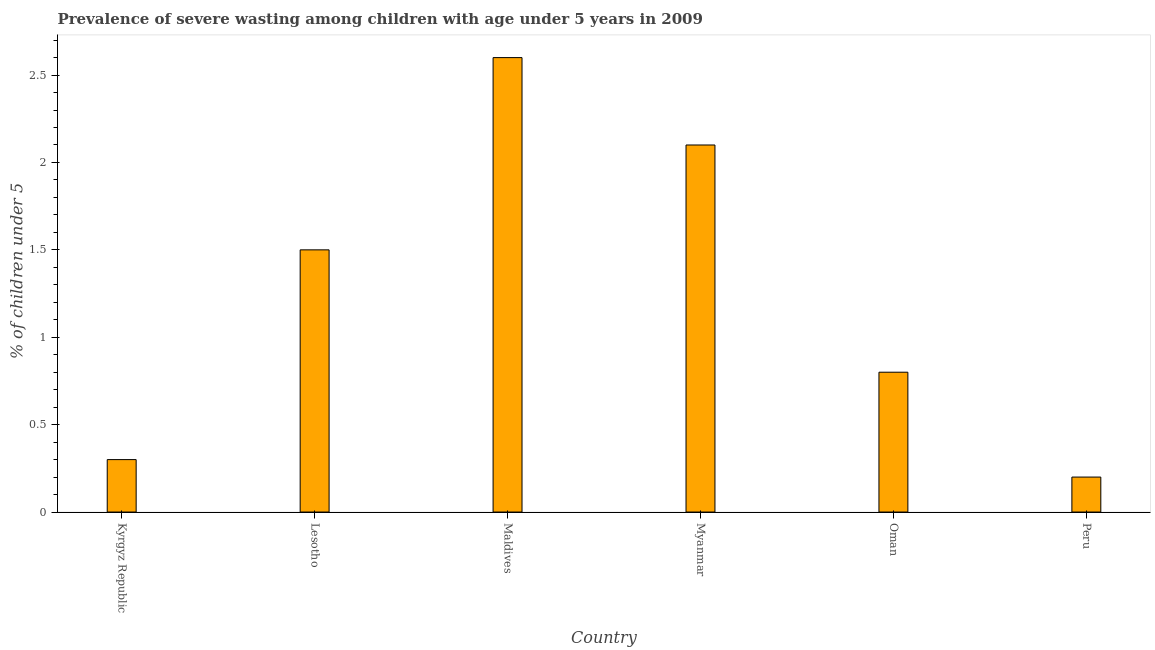Does the graph contain any zero values?
Keep it short and to the point. No. What is the title of the graph?
Your answer should be very brief. Prevalence of severe wasting among children with age under 5 years in 2009. What is the label or title of the X-axis?
Ensure brevity in your answer.  Country. What is the label or title of the Y-axis?
Keep it short and to the point.  % of children under 5. What is the prevalence of severe wasting in Maldives?
Give a very brief answer. 2.6. Across all countries, what is the maximum prevalence of severe wasting?
Give a very brief answer. 2.6. Across all countries, what is the minimum prevalence of severe wasting?
Ensure brevity in your answer.  0.2. In which country was the prevalence of severe wasting maximum?
Provide a short and direct response. Maldives. What is the sum of the prevalence of severe wasting?
Provide a succinct answer. 7.5. What is the average prevalence of severe wasting per country?
Provide a short and direct response. 1.25. What is the median prevalence of severe wasting?
Offer a terse response. 1.15. In how many countries, is the prevalence of severe wasting greater than 0.2 %?
Provide a succinct answer. 6. What is the ratio of the prevalence of severe wasting in Myanmar to that in Peru?
Keep it short and to the point. 10.5. Is the prevalence of severe wasting in Myanmar less than that in Peru?
Ensure brevity in your answer.  No. Are all the bars in the graph horizontal?
Offer a very short reply. No. Are the values on the major ticks of Y-axis written in scientific E-notation?
Give a very brief answer. No. What is the  % of children under 5 in Kyrgyz Republic?
Make the answer very short. 0.3. What is the  % of children under 5 of Maldives?
Make the answer very short. 2.6. What is the  % of children under 5 of Myanmar?
Give a very brief answer. 2.1. What is the  % of children under 5 in Oman?
Offer a very short reply. 0.8. What is the  % of children under 5 of Peru?
Your response must be concise. 0.2. What is the difference between the  % of children under 5 in Kyrgyz Republic and Myanmar?
Your response must be concise. -1.8. What is the difference between the  % of children under 5 in Kyrgyz Republic and Oman?
Provide a short and direct response. -0.5. What is the difference between the  % of children under 5 in Kyrgyz Republic and Peru?
Give a very brief answer. 0.1. What is the difference between the  % of children under 5 in Lesotho and Myanmar?
Your answer should be very brief. -0.6. What is the difference between the  % of children under 5 in Lesotho and Peru?
Offer a terse response. 1.3. What is the difference between the  % of children under 5 in Myanmar and Peru?
Offer a terse response. 1.9. What is the difference between the  % of children under 5 in Oman and Peru?
Ensure brevity in your answer.  0.6. What is the ratio of the  % of children under 5 in Kyrgyz Republic to that in Maldives?
Your answer should be compact. 0.12. What is the ratio of the  % of children under 5 in Kyrgyz Republic to that in Myanmar?
Make the answer very short. 0.14. What is the ratio of the  % of children under 5 in Lesotho to that in Maldives?
Keep it short and to the point. 0.58. What is the ratio of the  % of children under 5 in Lesotho to that in Myanmar?
Your response must be concise. 0.71. What is the ratio of the  % of children under 5 in Lesotho to that in Oman?
Your answer should be compact. 1.88. What is the ratio of the  % of children under 5 in Lesotho to that in Peru?
Provide a short and direct response. 7.5. What is the ratio of the  % of children under 5 in Maldives to that in Myanmar?
Make the answer very short. 1.24. What is the ratio of the  % of children under 5 in Maldives to that in Oman?
Ensure brevity in your answer.  3.25. What is the ratio of the  % of children under 5 in Maldives to that in Peru?
Give a very brief answer. 13. What is the ratio of the  % of children under 5 in Myanmar to that in Oman?
Provide a short and direct response. 2.62. What is the ratio of the  % of children under 5 in Myanmar to that in Peru?
Your answer should be compact. 10.5. What is the ratio of the  % of children under 5 in Oman to that in Peru?
Provide a succinct answer. 4. 